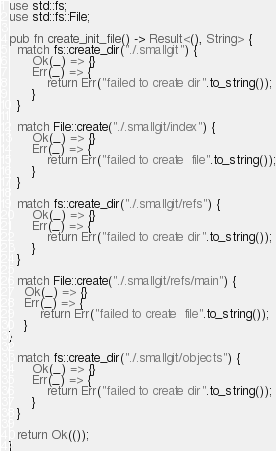<code> <loc_0><loc_0><loc_500><loc_500><_Rust_>use std::fs;
use std::fs::File;

pub fn create_init_file() -> Result<(), String> {
  match fs::create_dir("./.smallgit") {
      Ok(_) => {}
      Err(_) => {
          return Err("failed to create dir".to_string());
      }
  }

  match File::create("./.smallgit/index") {
      Ok(_) => {}
      Err(_) => {
          return Err("failed to create  file".to_string());
      }
  }

  match fs::create_dir("./.smallgit/refs") {
      Ok(_) => {}
      Err(_) => {
          return Err("failed to create dir".to_string());
      }
  }

  match File::create("./.smallgit/refs/main") {
    Ok(_) => {}
    Err(_) => {
        return Err("failed to create  file".to_string());
    }
}

  match fs::create_dir("./.smallgit/objects") {
      Ok(_) => {}
      Err(_) => {
          return Err("failed to create dir".to_string());
      }
  }

  return Ok(());
}
</code> 